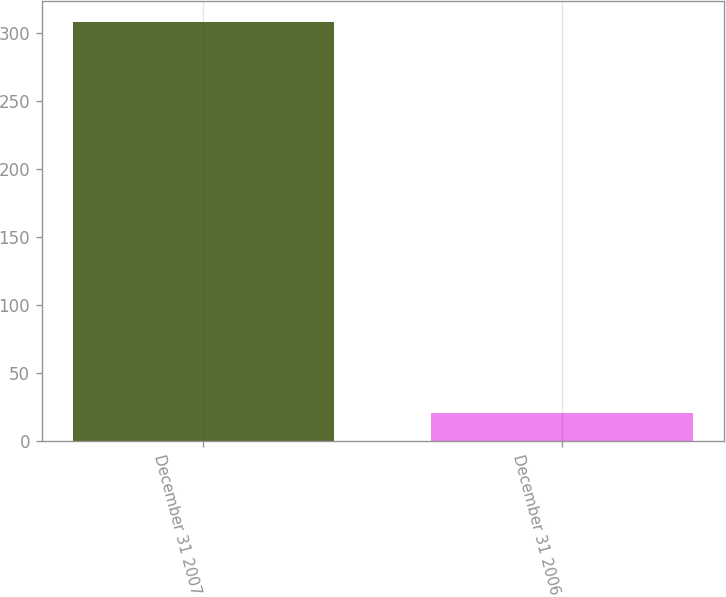<chart> <loc_0><loc_0><loc_500><loc_500><bar_chart><fcel>December 31 2007<fcel>December 31 2006<nl><fcel>308<fcel>21<nl></chart> 